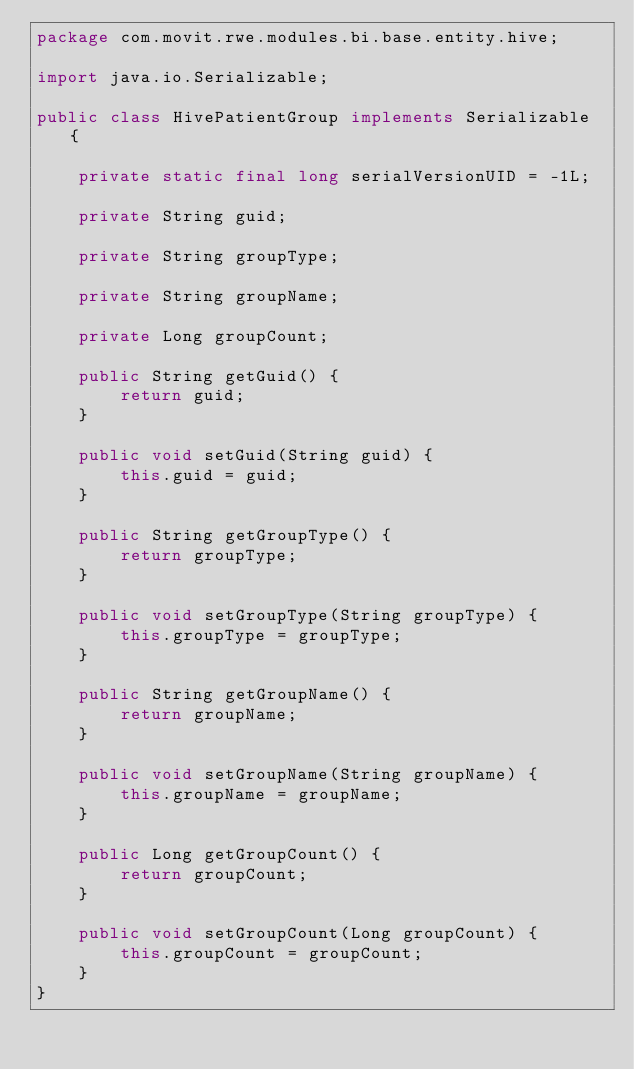<code> <loc_0><loc_0><loc_500><loc_500><_Java_>package com.movit.rwe.modules.bi.base.entity.hive;

import java.io.Serializable;

public class HivePatientGroup implements Serializable {

	private static final long serialVersionUID = -1L;

	private String guid;

	private String groupType;

	private String groupName;

	private Long groupCount;

	public String getGuid() {
		return guid;
	}

	public void setGuid(String guid) {
		this.guid = guid;
	}

	public String getGroupType() {
		return groupType;
	}

	public void setGroupType(String groupType) {
		this.groupType = groupType;
	}

	public String getGroupName() {
		return groupName;
	}

	public void setGroupName(String groupName) {
		this.groupName = groupName;
	}

	public Long getGroupCount() {
		return groupCount;
	}

	public void setGroupCount(Long groupCount) {
		this.groupCount = groupCount;
	}
}
</code> 